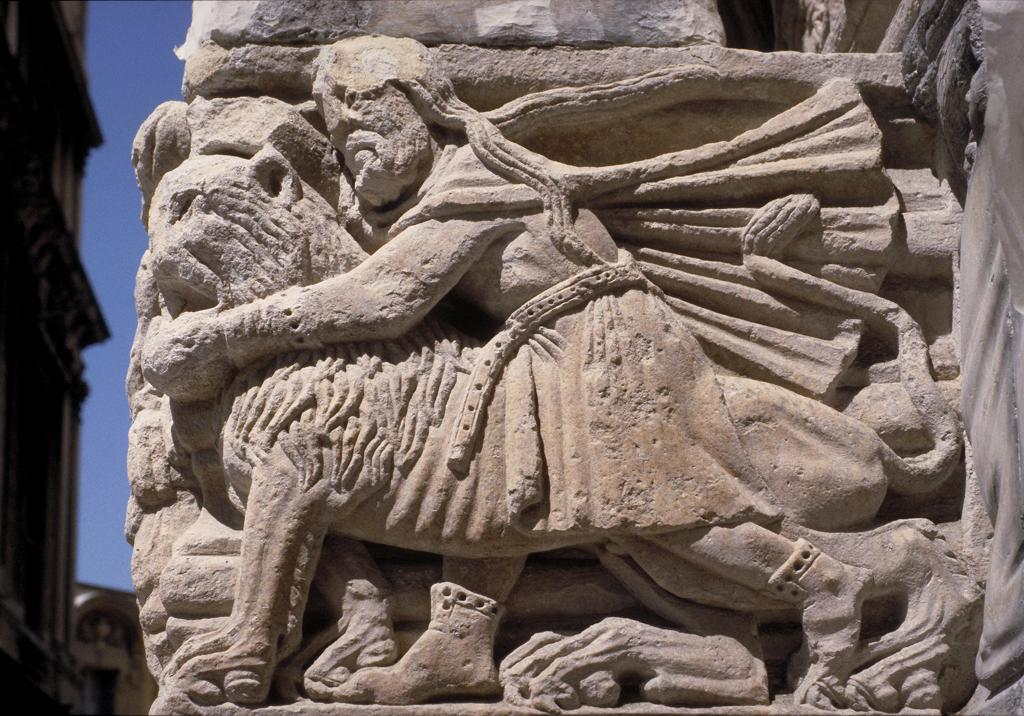What is the main subject of the image? The main subject of the image is a stone carving. What can be seen on the stone carving? The stone carving has an image. What is located on the left side of the image? There is a building on the left side of the image. What month is it in the image? The month cannot be determined from the image, as it does not contain any information about the time of year. 